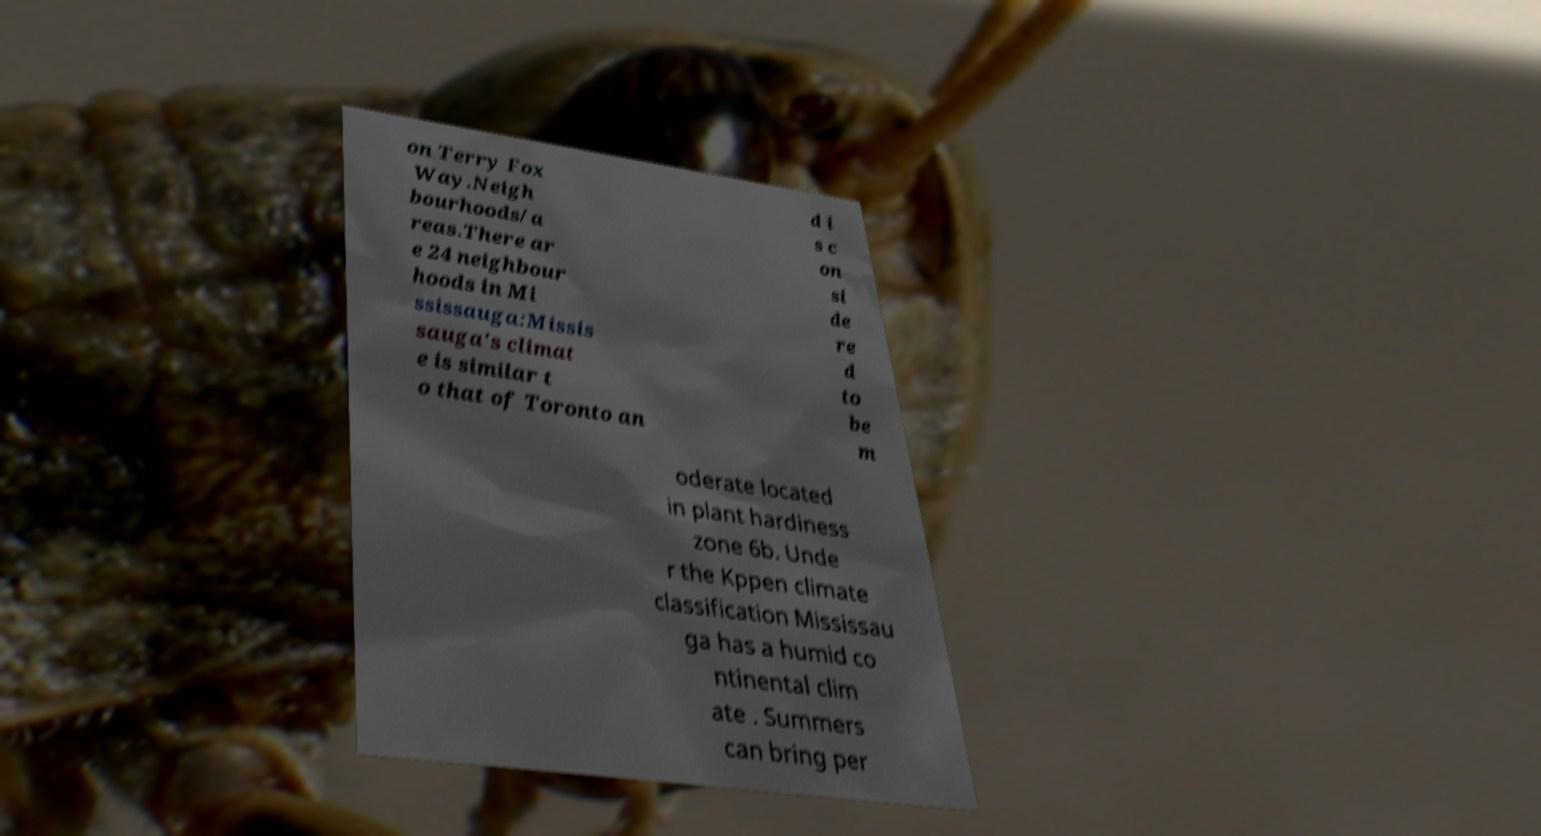There's text embedded in this image that I need extracted. Can you transcribe it verbatim? on Terry Fox Way.Neigh bourhoods/a reas.There ar e 24 neighbour hoods in Mi ssissauga:Missis sauga's climat e is similar t o that of Toronto an d i s c on si de re d to be m oderate located in plant hardiness zone 6b. Unde r the Kppen climate classification Mississau ga has a humid co ntinental clim ate . Summers can bring per 